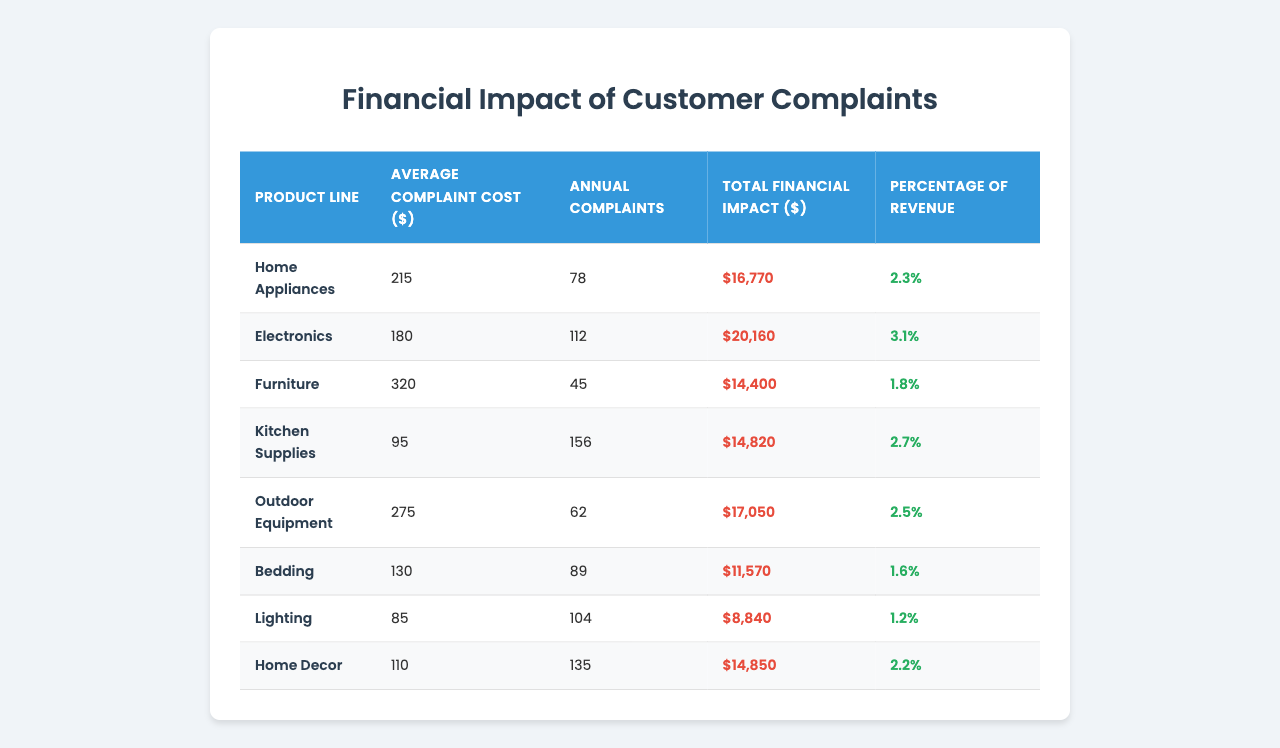What is the average complaint cost for the Electronics product line? The average complaint cost for Electronics is provided in the table under the "Average Complaint Cost ($)" column. The value is 180.
Answer: 180 How many annual complaints does the Furniture product line receive? The table lists the annual complaints for Furniture in the "Annual Complaints" column. The value is 45.
Answer: 45 What is the total financial impact of customer complaints on Home Appliances? The total financial impact is found in the table under the "Total Financial Impact ($)" column for Home Appliances, which shows a value of 16,770.
Answer: 16,770 Is the percentage of revenue lost due to complaints for Bedding greater than 2%? The percentage of revenue lost for Bedding is recorded in the table as 1.6%. Since this is less than 2%, the answer is no.
Answer: No Which product line has the highest average complaint cost? By comparing the values in the "Average Complaint Cost ($)" column, it is evident that Furniture has the highest at 320.
Answer: Furniture What is the total financial impact for Kitchen Supplies and Outdoor Equipment combined? To find this, we add the total financial impacts for both product lines as shown in the table. Kitchen Supplies has a total impact of 14,820 and Outdoor Equipment has 17,050. The sum is 14,820 + 17,050 = 31,870.
Answer: 31,870 How much financial impact does Home Decor have in comparison to Electronics? Home Decor's total financial impact is 14,850 while Electronics has 20,160. To compare, Home Decor generates 14,850 - 20,160 = -5,310, meaning it has less impact.
Answer: Home Decor has less impact by 5,310 Among all product lines, which one has the highest percentage of revenue loss due to complaints? The "Percentage of Revenue" column is analyzed, where Electronics has the highest percentage of 3.1%. Hence, it is identified as the product line with the highest percentage of revenue loss.
Answer: Electronics If the total revenue for Outdoor Equipment is $680,000, what is the total revenue lost due to complaints? The percentage of revenue lost for Outdoor Equipment is 2.5% as shown in the table. To calculate the total revenue lost, we apply: $680,000 * (2.5/100) = $17,000.
Answer: 17,000 Which product line has a smaller financial impact: Lighting or Bedding? By comparing Lighting's financial impact of 8,840 with Bedding's impact of 11,570, we see that Lighting is lower. Therefore, Lighting has a smaller financial impact.
Answer: Lighting 